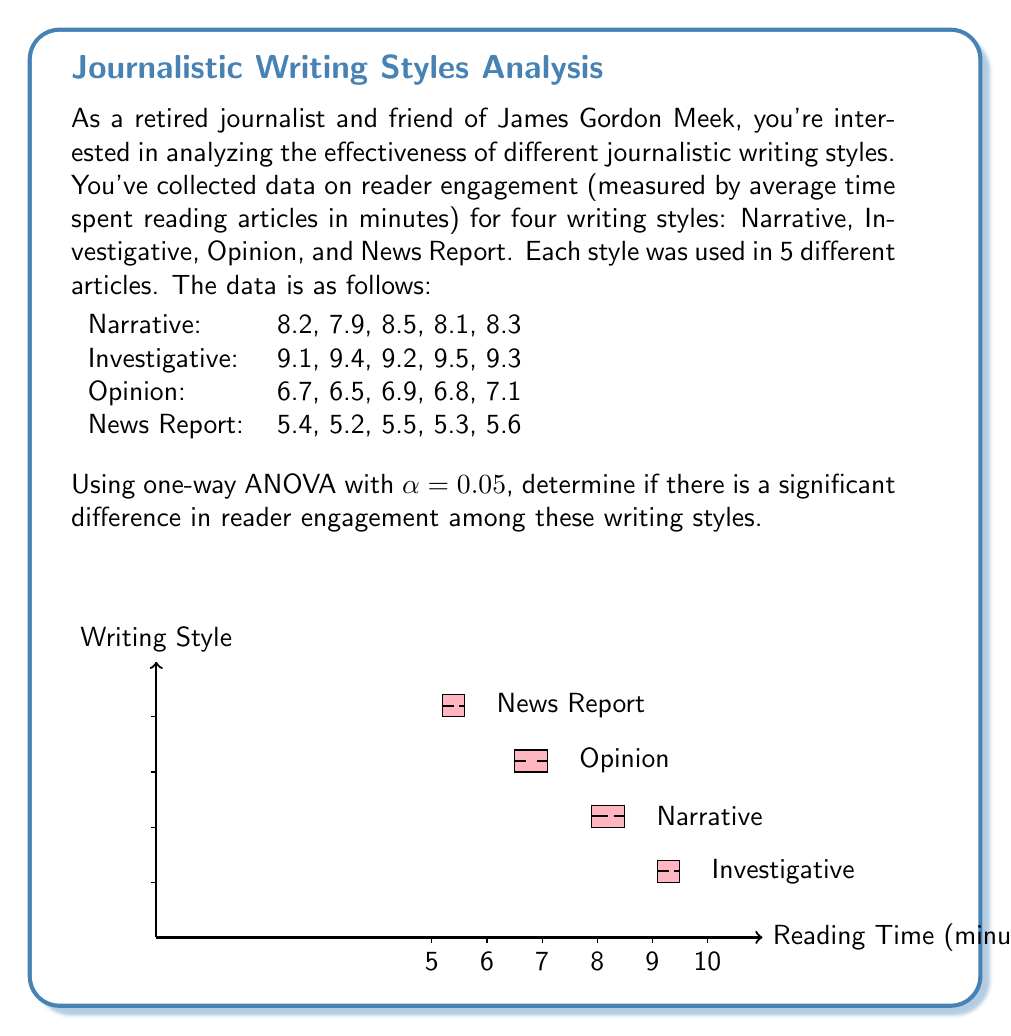Provide a solution to this math problem. To perform a one-way ANOVA, we'll follow these steps:

1) Calculate the means for each group:
   Narrative: $\bar{X}_1 = 8.2$
   Investigative: $\bar{X}_2 = 9.3$
   Opinion: $\bar{X}_3 = 6.8$
   News Report: $\bar{X}_4 = 5.4$

2) Calculate the grand mean:
   $\bar{X} = \frac{8.2 + 9.3 + 6.8 + 5.4}{4} = 7.425$

3) Calculate SSB (Sum of Squares Between):
   $$SSB = \sum_{i=1}^{k} n_i(\bar{X}_i - \bar{X})^2$$
   $$SSB = 5[(8.2-7.425)^2 + (9.3-7.425)^2 + (6.8-7.425)^2 + (5.4-7.425)^2] = 48.375$$

4) Calculate SSW (Sum of Squares Within):
   $$SSW = \sum_{i=1}^{k} \sum_{j=1}^{n_i} (X_{ij} - \bar{X}_i)^2$$
   $$SSW = 0.46 + 0.14 + 0.26 + 0.14 = 1.00$$

5) Calculate SST (Total Sum of Squares):
   $$SST = SSB + SSW = 48.375 + 1.00 = 49.375$$

6) Calculate degrees of freedom:
   dfB = k - 1 = 4 - 1 = 3
   dfW = N - k = 20 - 4 = 16
   dfT = N - 1 = 20 - 1 = 19

7) Calculate Mean Squares:
   $$MSB = \frac{SSB}{dfB} = \frac{48.375}{3} = 16.125$$
   $$MSW = \frac{SSW}{dfW} = \frac{1.00}{16} = 0.0625$$

8) Calculate F-statistic:
   $$F = \frac{MSB}{MSW} = \frac{16.125}{0.0625} = 258$$

9) Find the critical F-value:
   For α = 0.05, dfB = 3, and dfW = 16, the critical F-value is approximately 3.24.

10) Compare F-statistic to critical F-value:
    Since 258 > 3.24, we reject the null hypothesis.

Therefore, there is a significant difference in reader engagement among these writing styles at the 0.05 significance level.
Answer: Reject null hypothesis; F(3,16) = 258, p < 0.05 